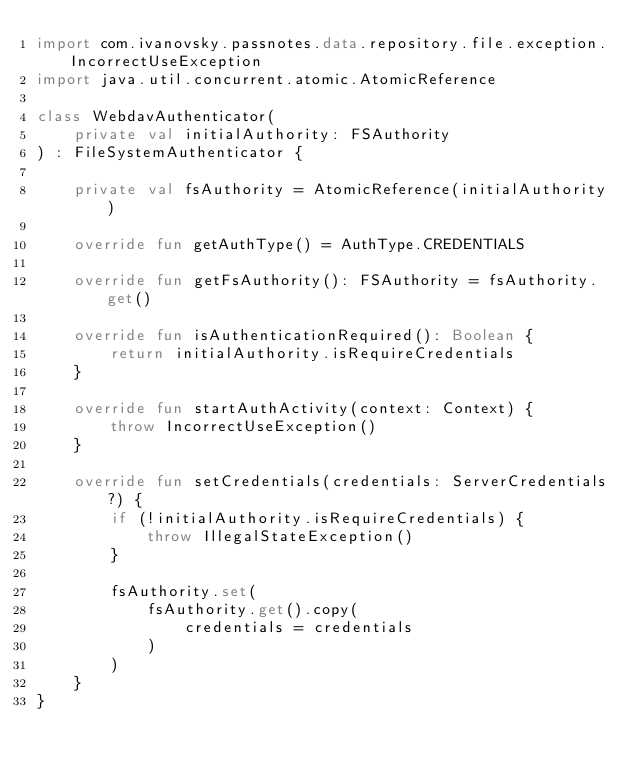<code> <loc_0><loc_0><loc_500><loc_500><_Kotlin_>import com.ivanovsky.passnotes.data.repository.file.exception.IncorrectUseException
import java.util.concurrent.atomic.AtomicReference

class WebdavAuthenticator(
    private val initialAuthority: FSAuthority
) : FileSystemAuthenticator {

    private val fsAuthority = AtomicReference(initialAuthority)

    override fun getAuthType() = AuthType.CREDENTIALS

    override fun getFsAuthority(): FSAuthority = fsAuthority.get()

    override fun isAuthenticationRequired(): Boolean {
        return initialAuthority.isRequireCredentials
    }

    override fun startAuthActivity(context: Context) {
        throw IncorrectUseException()
    }

    override fun setCredentials(credentials: ServerCredentials?) {
        if (!initialAuthority.isRequireCredentials) {
            throw IllegalStateException()
        }

        fsAuthority.set(
            fsAuthority.get().copy(
                credentials = credentials
            )
        )
    }
}</code> 